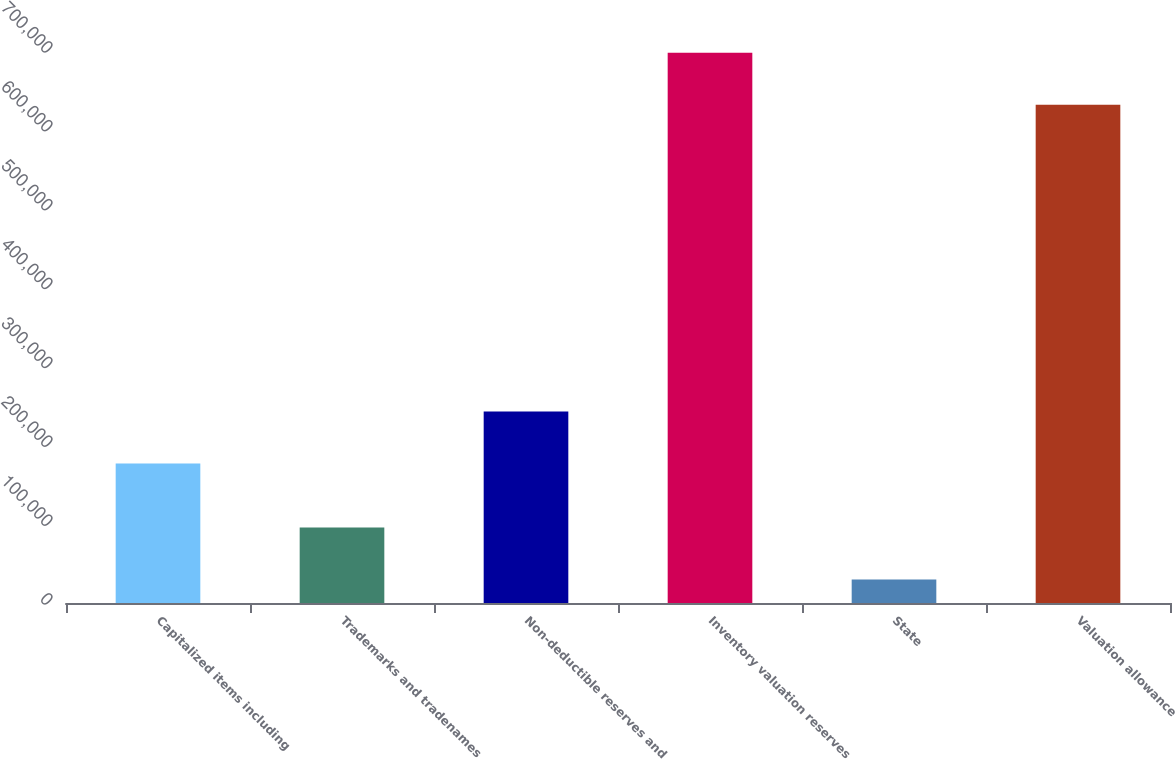<chart> <loc_0><loc_0><loc_500><loc_500><bar_chart><fcel>Capitalized items including<fcel>Trademarks and tradenames<fcel>Non-deductible reserves and<fcel>Inventory valuation reserves<fcel>State<fcel>Valuation allowance<nl><fcel>176995<fcel>95819.8<fcel>242908<fcel>697797<fcel>29907<fcel>631884<nl></chart> 